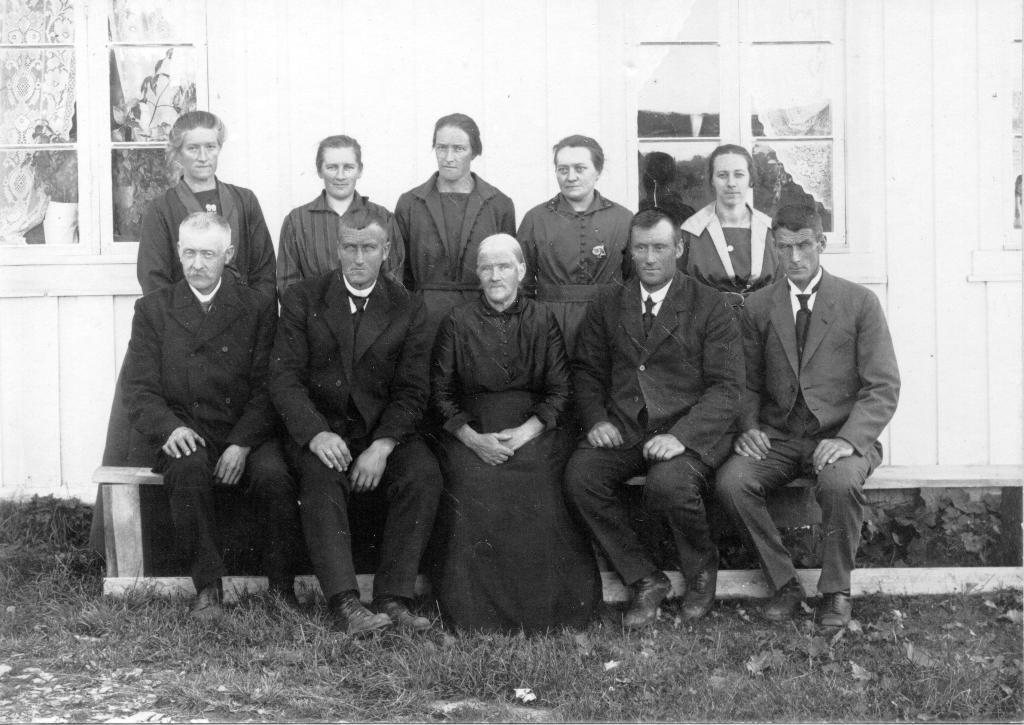What are the people in the image doing? Some people are standing, and others are sitting in the image. What type of surface is at the bottom of the image? There is grass at the bottom of the image. How many windows can be seen in the background? There are two windows visible in the background. What is the color scheme of the image? The image is black and white. Can you tell me how many eggs are on the table in the image? There is no table or eggs present in the image. What type of animal is the chicken in the image? There is no chicken present in the image. 